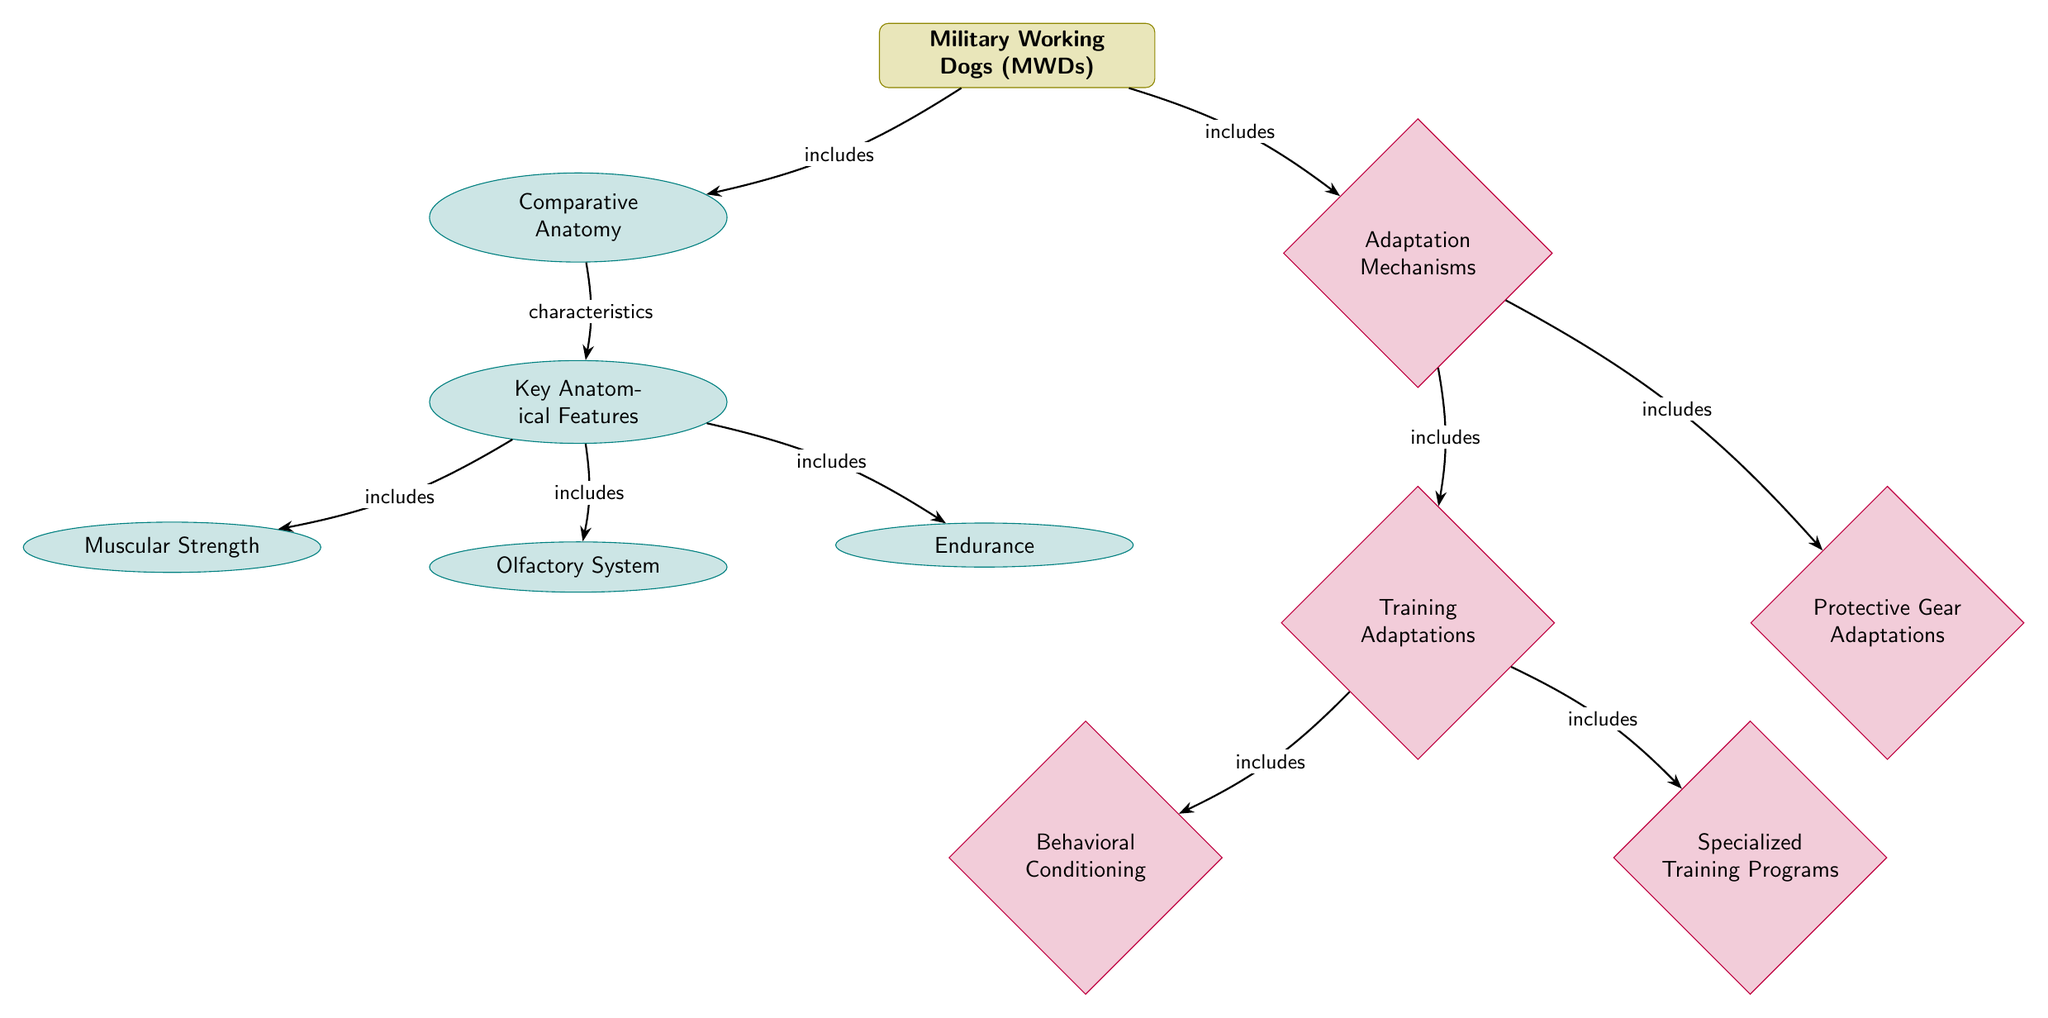What's the main subject of the diagram? The diagram's main subject is highlighted at the top, labeled "Military Working Dogs (MWDs)", indicating that the entire diagram revolves around this topic.
Answer: Military Working Dogs (MWDs) How many key anatomical features are identified? The "Key Anatomical Features" node is connected directly below the "Comparative Anatomy" node and has three branches leading to "Muscular Strength", "Olfactory System", and "Endurance", which counts as a total of three identified features.
Answer: 3 What type of adaptation mechanism is represented by "Behavioral Conditioning"? "Behavioral Conditioning" is located under the "Training Adaptations" category, which is a form of adaptation mechanism focusing on training methods used for military working dogs.
Answer: Training Adaptations What relationship exists between "Military Working Dogs (MWDs)" and "Comparative Anatomy"? The arrow from "Military Working Dogs (MWDs)" to "Comparative Anatomy" signifies that "Military Working Dogs (MWDs)" includes "Comparative Anatomy" as part of its characteristics or study scope.
Answer: includes Which adaptation mechanism is related to protective gear? The "Protective Gear Adaptations" node is positioned to the right of the "Training Adaptations" node, indicating it is another form of adaptation mechanism relevant to military working dogs.
Answer: Protective Gear Adaptations What are the three specific anatomical features of Military Working Dogs? Taking into account the branches from the "Key Anatomical Features" node, "Muscular Strength", "Olfactory System", and "Endurance" are the three specific features highlighted in the diagram.
Answer: Muscular Strength, Olfactory System, Endurance Which adaptation mechanism involves specialized training? "Specialized Training Programs" is a component of the "Training Adaptations" block, indicating it is an adaptation mechanism specifically focusing on training designed for military working dogs.
Answer: Specialized Training Programs How many adaptation mechanisms are listed in the diagram? The adaptation node connects to three distinct entities: "Training Adaptations" (which includes two more components) and "Protective Gear Adaptations", yielding a total of four mechanisms when counted collectively.
Answer: 4 What do the arrows represent in the context of the diagram? The arrows indicate the relationships and connections between the main subject and its features, illustrating how components are categorized and linked, such as inclusion and characteristics.
Answer: Relationships 